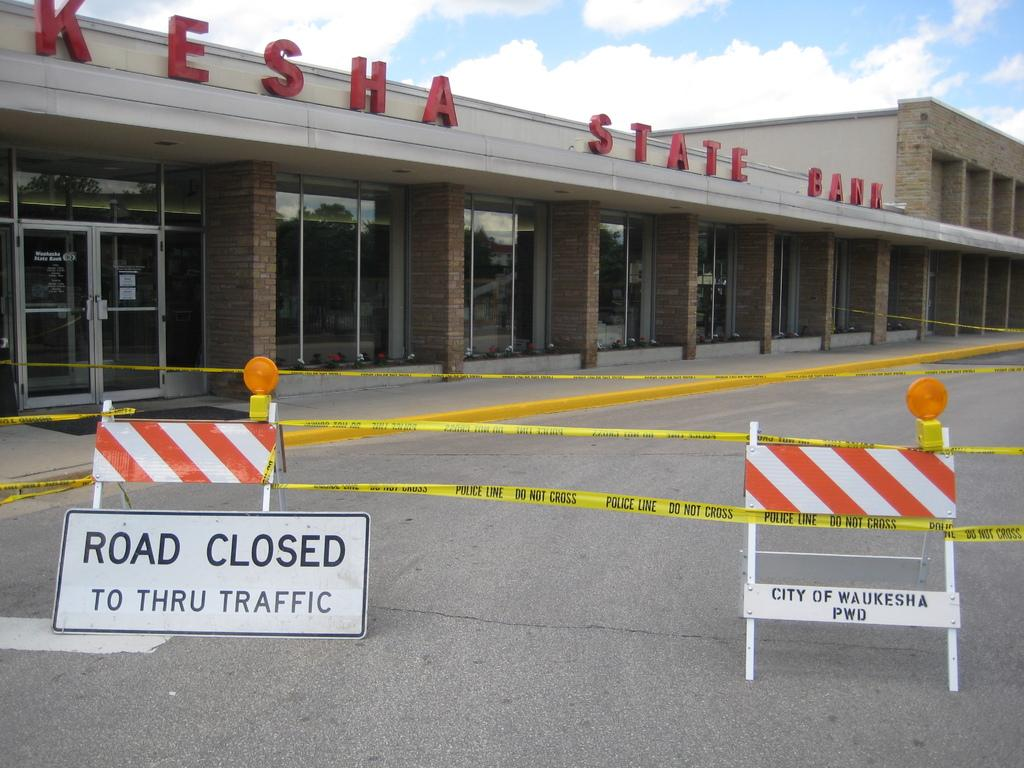What type of building is in the image? There is a large bank in the image. What is in front of the bank? There is a road in front of the bank. What is the status of the road? The road is closed. What can be seen near the closed road? There are caution boards in front of the road. What can be seen in the background of the image? The sky is visible in the background of the image. What type of blade is being used by the doll in the image? There is no doll or blade present in the image. 